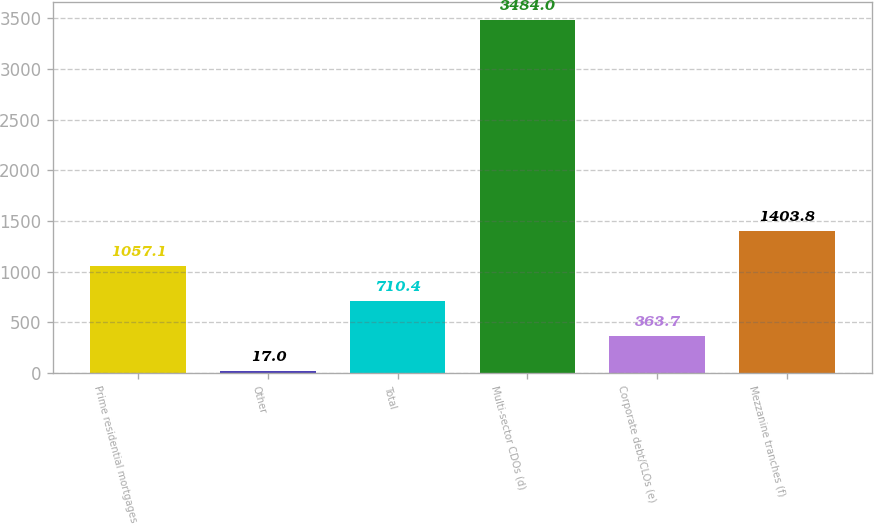Convert chart to OTSL. <chart><loc_0><loc_0><loc_500><loc_500><bar_chart><fcel>Prime residential mortgages<fcel>Other<fcel>Total<fcel>Multi-sector CDOs (d)<fcel>Corporate debt/CLOs (e)<fcel>Mezzanine tranches (f)<nl><fcel>1057.1<fcel>17<fcel>710.4<fcel>3484<fcel>363.7<fcel>1403.8<nl></chart> 